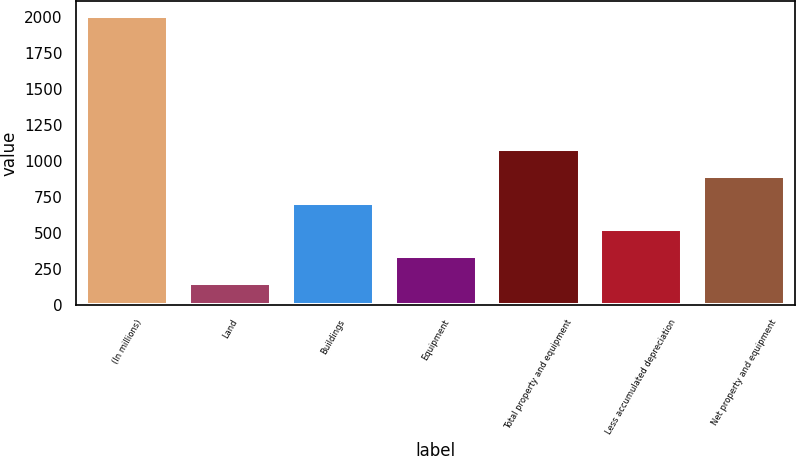Convert chart. <chart><loc_0><loc_0><loc_500><loc_500><bar_chart><fcel>(In millions)<fcel>Land<fcel>Buildings<fcel>Equipment<fcel>Total property and equipment<fcel>Less accumulated depreciation<fcel>Net property and equipment<nl><fcel>2009<fcel>153<fcel>709.8<fcel>338.6<fcel>1081<fcel>524.2<fcel>895.4<nl></chart> 